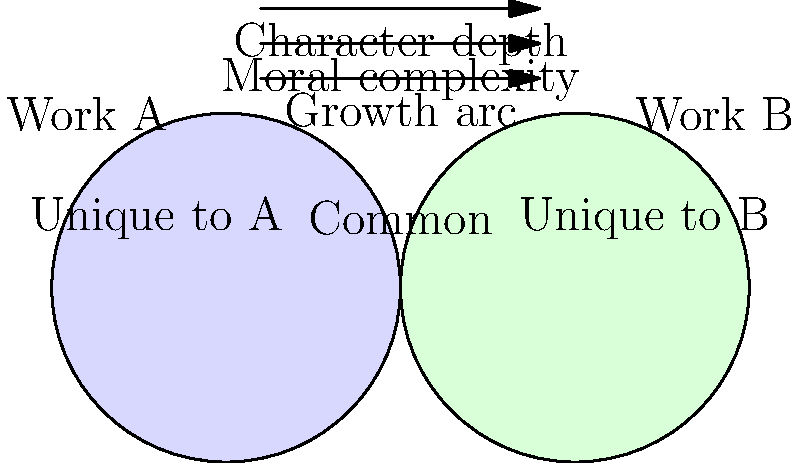In your role as a literature professor offering internships, you want to assess students' ability to analyze character development across different works. Using the Venn diagram provided, identify three key aspects of character development that are common to both Work A and Work B, and explain how these elements contribute to a comprehensive understanding of character evolution in literature. To answer this question, we need to analyze the Venn diagram and identify the elements in the overlapping section, which represents common aspects between Work A and Work B. The diagram clearly shows three key aspects of character development that are shared:

1. Character depth: This refers to the complexity and multi-dimensionality of characters. In both works, characters likely exhibit various layers of personality, motivations, and internal conflicts, making them more realistic and relatable.

2. Moral complexity: This aspect indicates that characters in both works face moral dilemmas or ambiguous situations. They may struggle with difficult decisions, showcasing the nuances of human behavior and ethics.

3. Growth arc: This element suggests that characters in both works undergo significant changes or development throughout the story. They likely learn, adapt, and evolve in response to the events and challenges they face.

These three aspects contribute to a comprehensive understanding of character evolution in literature by:

a) Providing a multi-faceted view of characters, allowing readers to connect with them on various levels.
b) Demonstrating the complexity of human nature and decision-making processes.
c) Illustrating how characters change and develop over time, reflecting real-life personal growth and adaptation.

By analyzing these common elements across different works, students can develop a deeper appreciation for the craft of character development and its role in storytelling.
Answer: Character depth, moral complexity, and growth arc are common aspects that contribute to comprehensive character evolution by providing multi-faceted views, demonstrating human complexity, and illustrating character change over time. 